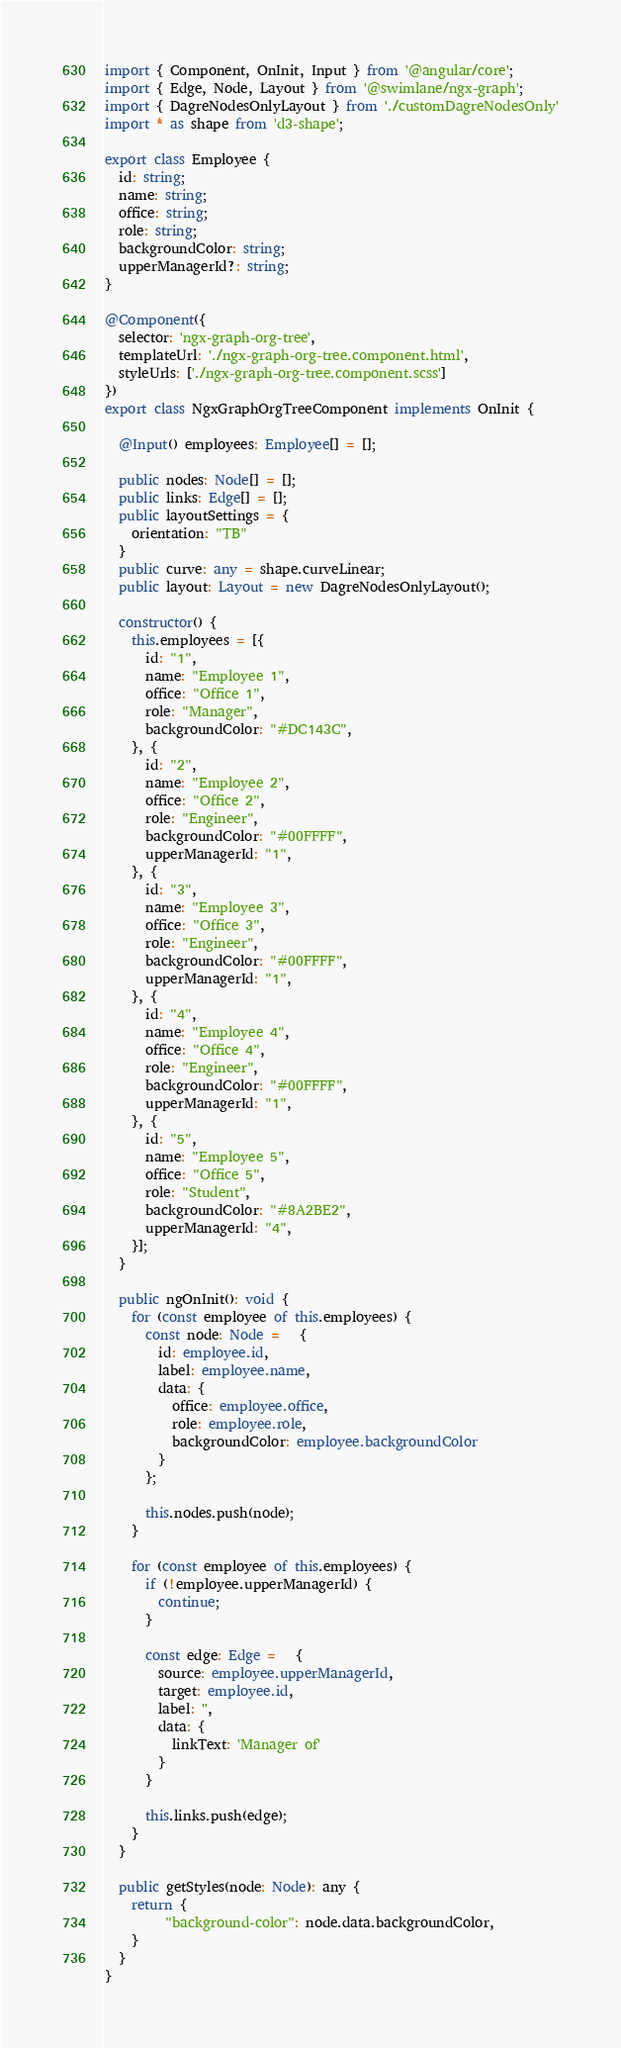<code> <loc_0><loc_0><loc_500><loc_500><_TypeScript_>import { Component, OnInit, Input } from '@angular/core';
import { Edge, Node, Layout } from '@swimlane/ngx-graph';
import { DagreNodesOnlyLayout } from './customDagreNodesOnly'
import * as shape from 'd3-shape';

export class Employee {
  id: string;
  name: string;
  office: string;
  role: string;
  backgroundColor: string;
  upperManagerId?: string;
}

@Component({
  selector: 'ngx-graph-org-tree',
  templateUrl: './ngx-graph-org-tree.component.html',
  styleUrls: ['./ngx-graph-org-tree.component.scss']
})
export class NgxGraphOrgTreeComponent implements OnInit {

  @Input() employees: Employee[] = [];

  public nodes: Node[] = [];
  public links: Edge[] = [];
  public layoutSettings = {
    orientation: "TB"
  }
  public curve: any = shape.curveLinear;
  public layout: Layout = new DagreNodesOnlyLayout();

  constructor() {
    this.employees = [{
      id: "1",
      name: "Employee 1",
      office: "Office 1",
      role: "Manager",
      backgroundColor: "#DC143C",
    }, {
      id: "2",
      name: "Employee 2",
      office: "Office 2",
      role: "Engineer",
      backgroundColor: "#00FFFF",
      upperManagerId: "1",
    }, {
      id: "3",
      name: "Employee 3",
      office: "Office 3",
      role: "Engineer",
      backgroundColor: "#00FFFF",
      upperManagerId: "1",
    }, {
      id: "4",
      name: "Employee 4",
      office: "Office 4",
      role: "Engineer",
      backgroundColor: "#00FFFF",
      upperManagerId: "1",
    }, {
      id: "5",
      name: "Employee 5",
      office: "Office 5",
      role: "Student",
      backgroundColor: "#8A2BE2",
      upperManagerId: "4",
    }];
  }

  public ngOnInit(): void {
    for (const employee of this.employees) {
      const node: Node =   {
        id: employee.id,
        label: employee.name,
        data: {
          office: employee.office,
          role: employee.role,
          backgroundColor: employee.backgroundColor
        }
      };

      this.nodes.push(node);
    }

    for (const employee of this.employees) {
      if (!employee.upperManagerId) {
        continue;
      }

      const edge: Edge =   {
        source: employee.upperManagerId,
        target: employee.id,
        label: '',
        data: {
          linkText: 'Manager of'
        }
      }

      this.links.push(edge);
    }
  }

  public getStyles(node: Node): any {
    return {
         "background-color": node.data.backgroundColor,
    }
  }
}
</code> 